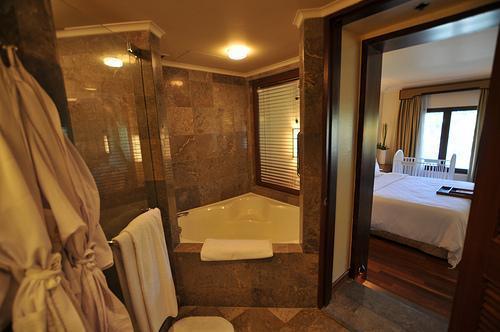How many rooms are in the picture?
Give a very brief answer. 2. How many bathrobes are there?
Give a very brief answer. 2. 